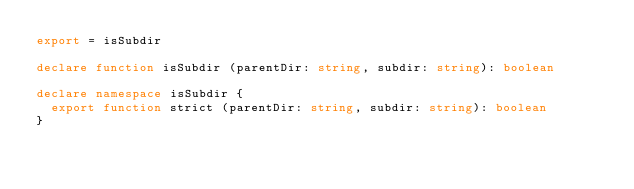<code> <loc_0><loc_0><loc_500><loc_500><_TypeScript_>export = isSubdir

declare function isSubdir (parentDir: string, subdir: string): boolean

declare namespace isSubdir {
  export function strict (parentDir: string, subdir: string): boolean
}
</code> 